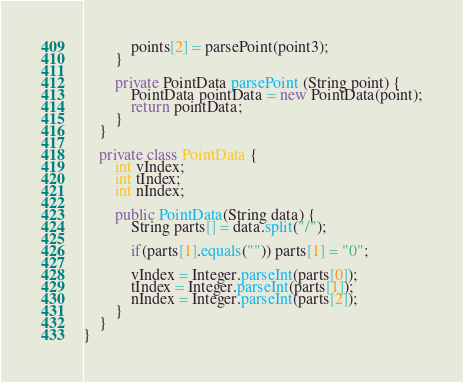Convert code to text. <code><loc_0><loc_0><loc_500><loc_500><_Java_>            points[2] = parsePoint(point3);
        }

        private PointData parsePoint (String point) {
            PointData pointData = new PointData(point);
            return pointData;
        }
    }

    private class PointData {
        int vIndex;
        int tIndex;
        int nIndex;

        public PointData(String data) {
            String parts[] = data.split("/");

            if(parts[1].equals("")) parts[1] = "0";

            vIndex = Integer.parseInt(parts[0]);
            tIndex = Integer.parseInt(parts[1]);
            nIndex = Integer.parseInt(parts[2]);
        }
    }
}
</code> 